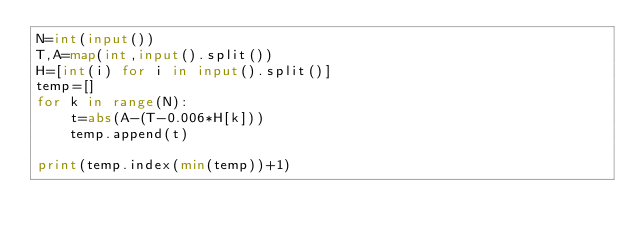Convert code to text. <code><loc_0><loc_0><loc_500><loc_500><_Python_>N=int(input())
T,A=map(int,input().split())
H=[int(i) for i in input().split()]
temp=[]
for k in range(N):
    t=abs(A-(T-0.006*H[k]))
    temp.append(t)

print(temp.index(min(temp))+1)
</code> 